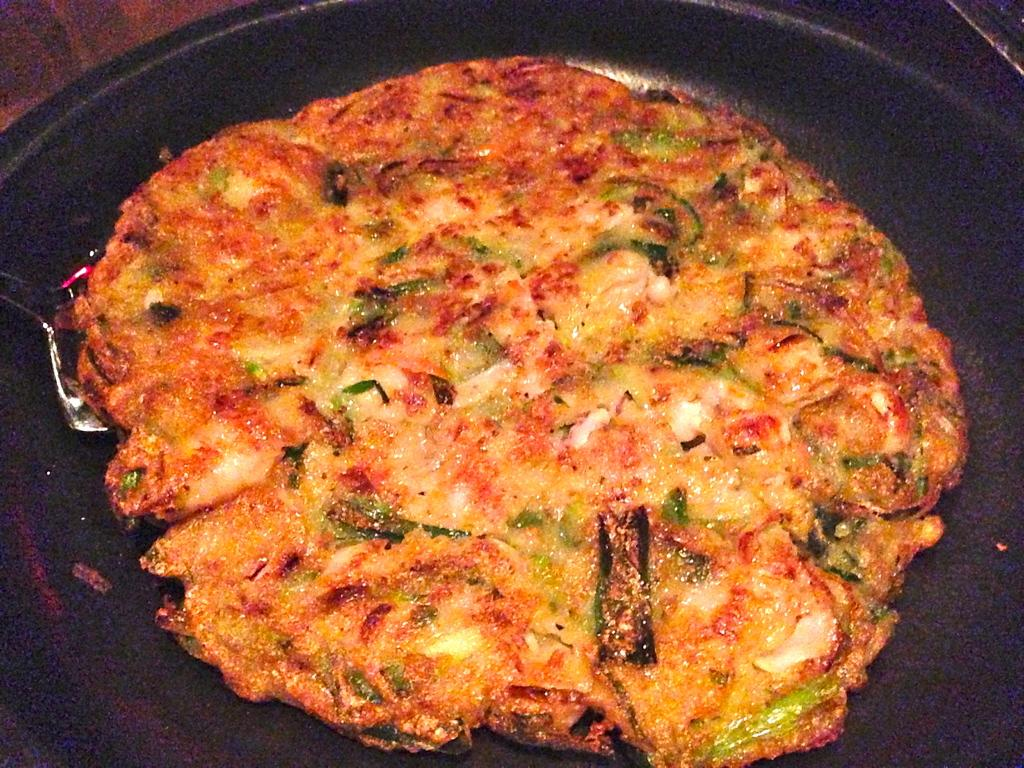What is the main subject of the image? A: The main subject of the image is a food item on a pan. Can you describe any utensils or tools in the image? Yes, there is a spatula on the left side of the image. What type of yarn is being used to hold the food item on the pan in the image? There is no yarn present in the image; the food item is on a pan and not being held by any yarn. 